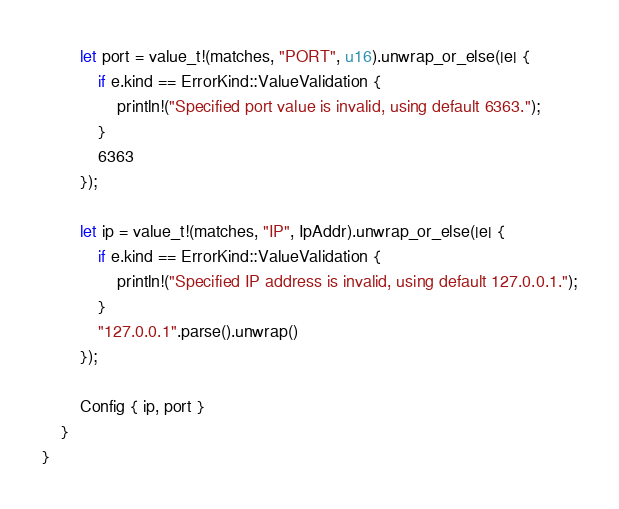Convert code to text. <code><loc_0><loc_0><loc_500><loc_500><_Rust_>        let port = value_t!(matches, "PORT", u16).unwrap_or_else(|e| {
            if e.kind == ErrorKind::ValueValidation {
                println!("Specified port value is invalid, using default 6363.");
            }
            6363
        });

        let ip = value_t!(matches, "IP", IpAddr).unwrap_or_else(|e| {
            if e.kind == ErrorKind::ValueValidation {
                println!("Specified IP address is invalid, using default 127.0.0.1.");
            }
            "127.0.0.1".parse().unwrap()
        });

        Config { ip, port }
    }
}
</code> 